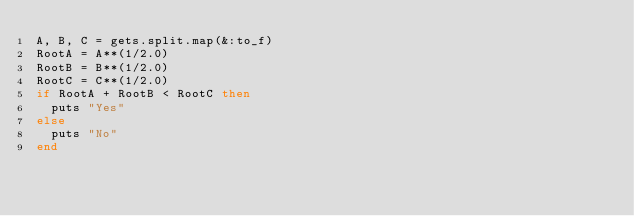<code> <loc_0><loc_0><loc_500><loc_500><_Ruby_>A, B, C = gets.split.map(&:to_f)
RootA = A**(1/2.0)
RootB = B**(1/2.0)
RootC = C**(1/2.0)
if RootA + RootB < RootC then
  puts "Yes"
else
  puts "No"
end</code> 